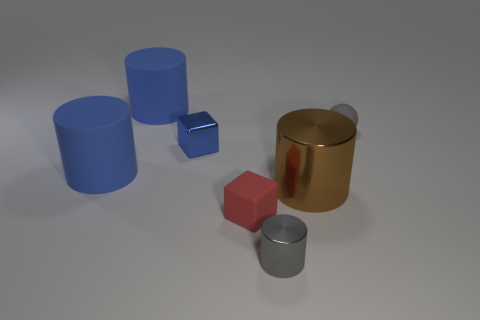Subtract 1 cylinders. How many cylinders are left? 3 Add 2 large cyan metal cylinders. How many objects exist? 9 Subtract all blocks. How many objects are left? 5 Subtract all large green shiny blocks. Subtract all large brown cylinders. How many objects are left? 6 Add 4 gray rubber objects. How many gray rubber objects are left? 5 Add 2 big gray balls. How many big gray balls exist? 2 Subtract 0 red cylinders. How many objects are left? 7 